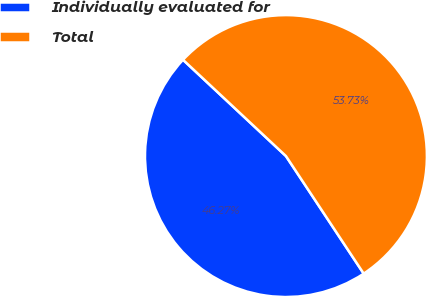Convert chart to OTSL. <chart><loc_0><loc_0><loc_500><loc_500><pie_chart><fcel>Individually evaluated for<fcel>Total<nl><fcel>46.27%<fcel>53.73%<nl></chart> 